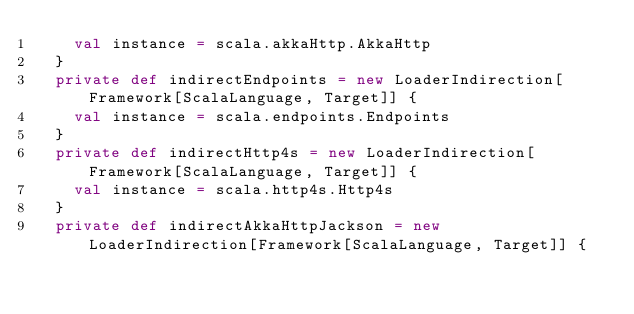<code> <loc_0><loc_0><loc_500><loc_500><_Scala_>    val instance = scala.akkaHttp.AkkaHttp
  }
  private def indirectEndpoints = new LoaderIndirection[Framework[ScalaLanguage, Target]] {
    val instance = scala.endpoints.Endpoints
  }
  private def indirectHttp4s = new LoaderIndirection[Framework[ScalaLanguage, Target]] {
    val instance = scala.http4s.Http4s
  }
  private def indirectAkkaHttpJackson = new LoaderIndirection[Framework[ScalaLanguage, Target]] {</code> 